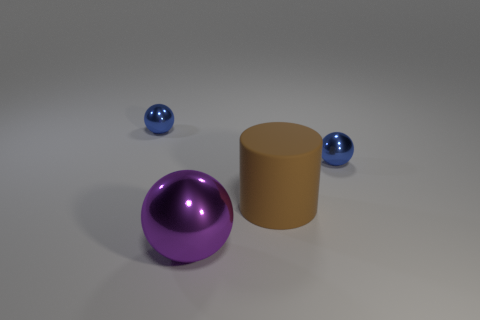Subtract all purple balls. How many balls are left? 2 Subtract 2 spheres. How many spheres are left? 1 Add 3 red matte cubes. How many objects exist? 7 Subtract all blue spheres. How many spheres are left? 1 Subtract all spheres. How many objects are left? 1 Subtract all yellow spheres. Subtract all brown blocks. How many spheres are left? 3 Subtract all green cylinders. How many red balls are left? 0 Subtract all big green metal objects. Subtract all brown cylinders. How many objects are left? 3 Add 4 big metal balls. How many big metal balls are left? 5 Add 4 yellow rubber balls. How many yellow rubber balls exist? 4 